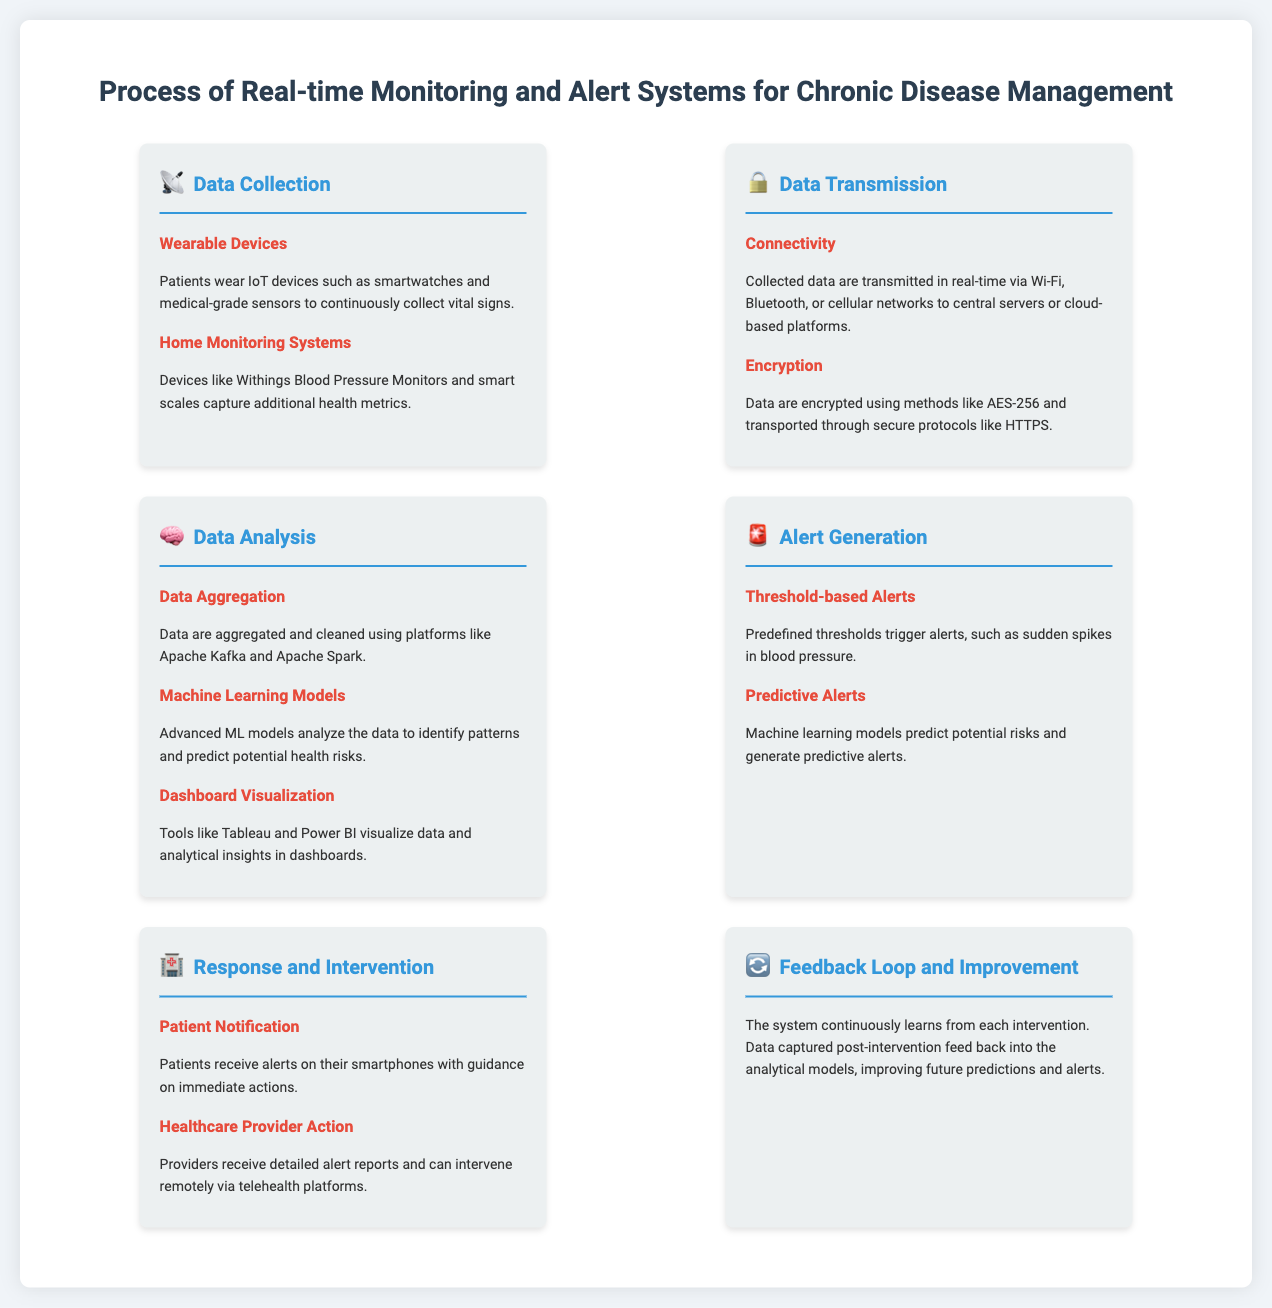What devices are used for data collection? The document mentions wearable devices like smartwatches and medical-grade sensors, as well as home monitoring systems like Withings Blood Pressure Monitors.
Answer: Smartwatches and Withings Blood Pressure Monitors What method is used for data encryption? The document states that data are encrypted using methods like AES-256.
Answer: AES-256 What technology is mentioned for data aggregation? The infographic specifies platforms like Apache Kafka and Apache Spark for data aggregation.
Answer: Apache Kafka and Apache Spark What type of alerts are triggered by sudden spikes in blood pressure? The document refers to these as threshold-based alerts.
Answer: Threshold-based alerts Which tools are used for dashboard visualization? According to the document, tools like Tableau and Power BI are used for visualization.
Answer: Tableau and Power BI What is the purpose of the feedback loop in the process? The feedback loop allows the system to continuously learn from each intervention and improve future predictions and alerts.
Answer: Improve future predictions How are patients notified in the response and intervention step? The document states that patients receive alerts on their smartphones.
Answer: Smartphones What type of alerts do machine learning models generate? The document mentions that machine learning models generate predictive alerts.
Answer: Predictive alerts 